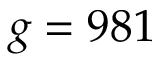Convert formula to latex. <formula><loc_0><loc_0><loc_500><loc_500>g = 9 8 1</formula> 